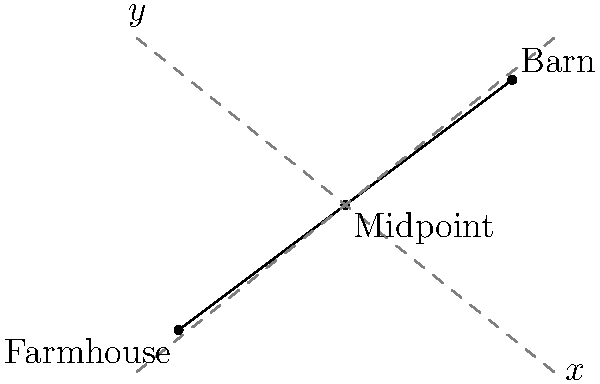Farmer John's property has a farmhouse located at (0,0) and a barn located at (8,6) on a coordinate plane. He wants to build a new storage shed at the midpoint between these two structures. What are the coordinates of the ideal location for the new storage shed? To find the midpoint of a line segment, we can use the midpoint formula:

$$ \text{Midpoint} = \left(\frac{x_1 + x_2}{2}, \frac{y_1 + y_2}{2}\right) $$

Where $(x_1, y_1)$ are the coordinates of the first point (farmhouse) and $(x_2, y_2)$ are the coordinates of the second point (barn).

Let's apply this formula to our problem:

1. Farmhouse coordinates: $(0, 0)$
2. Barn coordinates: $(8, 6)$

Now, let's calculate the x-coordinate of the midpoint:
$$ x = \frac{x_1 + x_2}{2} = \frac{0 + 8}{2} = \frac{8}{2} = 4 $$

Next, let's calculate the y-coordinate of the midpoint:
$$ y = \frac{y_1 + y_2}{2} = \frac{0 + 6}{2} = \frac{6}{2} = 3 $$

Therefore, the coordinates of the midpoint, where Farmer John should build his new storage shed, are (4, 3).
Answer: (4, 3) 